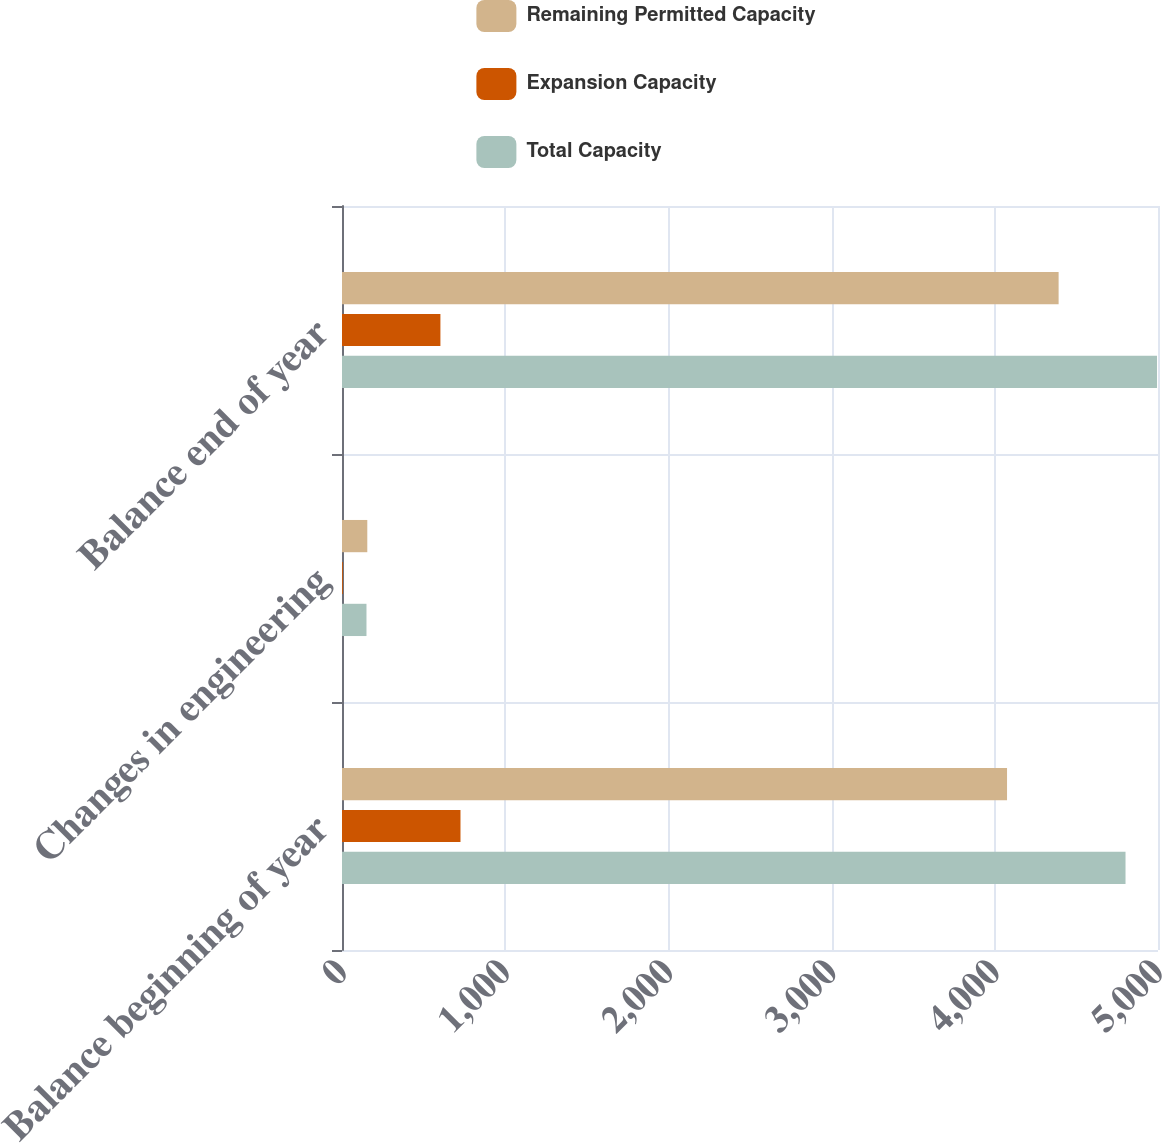<chart> <loc_0><loc_0><loc_500><loc_500><stacked_bar_chart><ecel><fcel>Balance beginning of year<fcel>Changes in engineering<fcel>Balance end of year<nl><fcel>Remaining Permitted Capacity<fcel>4075<fcel>155<fcel>4391<nl><fcel>Expansion Capacity<fcel>726<fcel>5<fcel>603<nl><fcel>Total Capacity<fcel>4801<fcel>150<fcel>4994<nl></chart> 